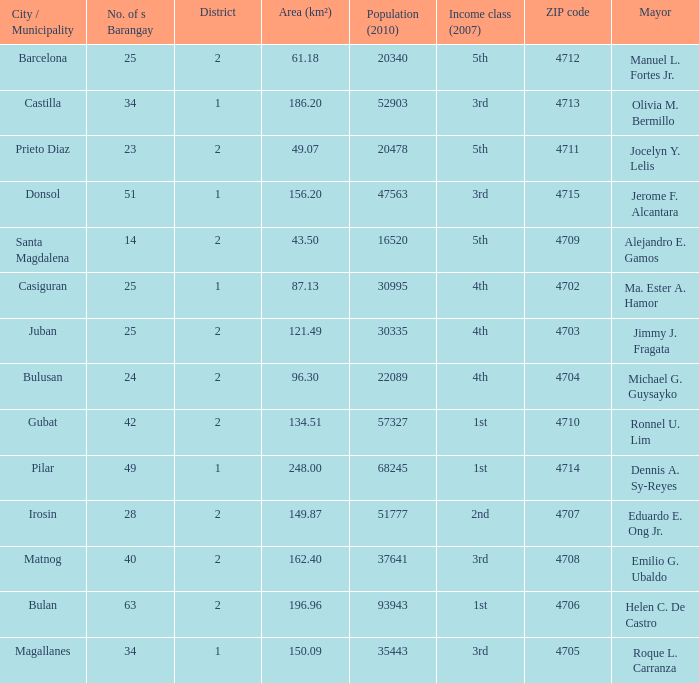What is the total quantity of populace (2010) where location (km²) is 134.51 1.0. 